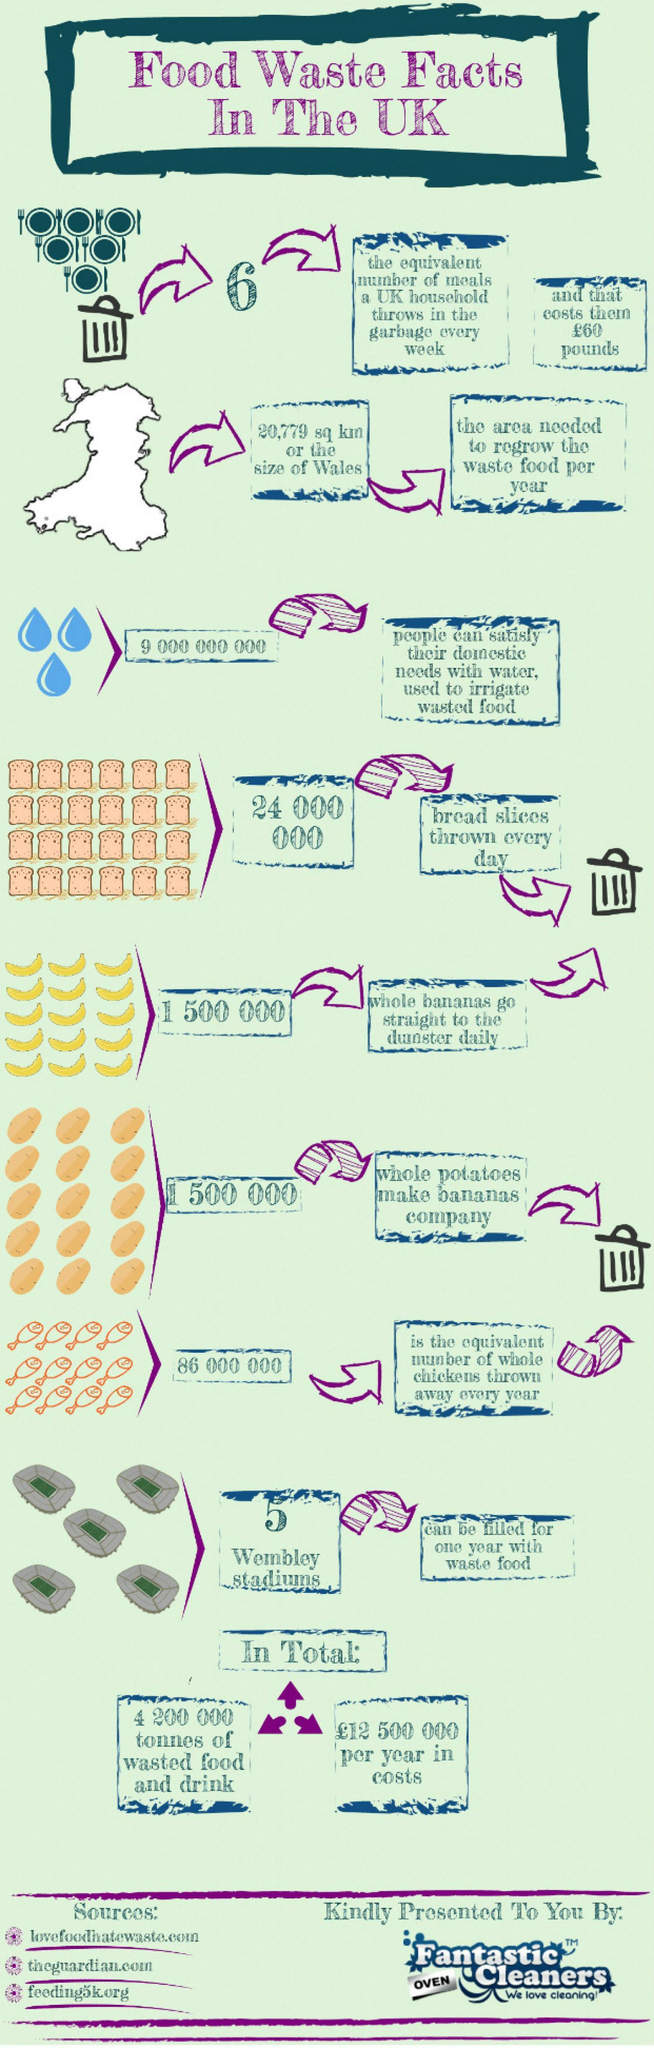How many bread slices are thrown away everyday in the UK?
Answer the question with a short phrase. 24 000 000 